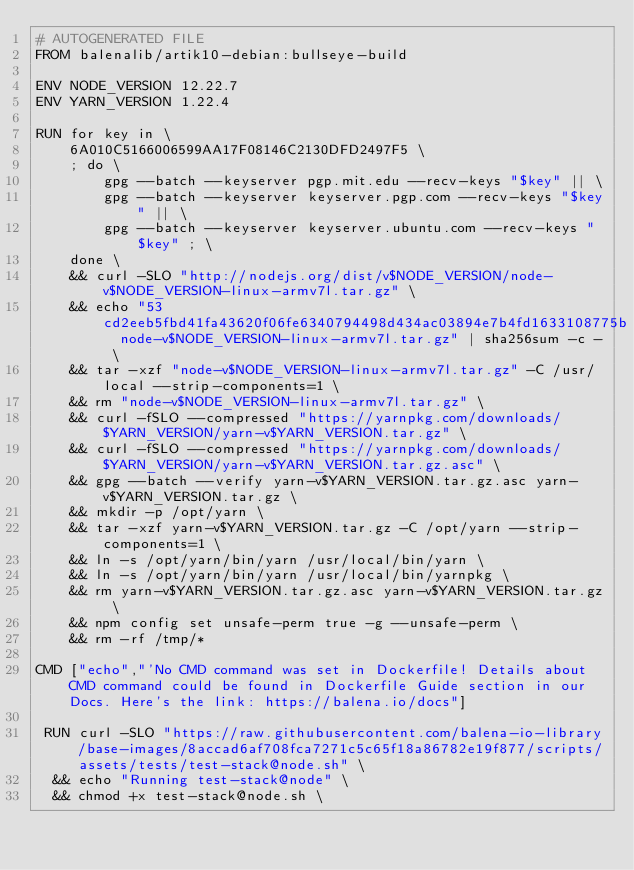<code> <loc_0><loc_0><loc_500><loc_500><_Dockerfile_># AUTOGENERATED FILE
FROM balenalib/artik10-debian:bullseye-build

ENV NODE_VERSION 12.22.7
ENV YARN_VERSION 1.22.4

RUN for key in \
	6A010C5166006599AA17F08146C2130DFD2497F5 \
	; do \
		gpg --batch --keyserver pgp.mit.edu --recv-keys "$key" || \
		gpg --batch --keyserver keyserver.pgp.com --recv-keys "$key" || \
		gpg --batch --keyserver keyserver.ubuntu.com --recv-keys "$key" ; \
	done \
	&& curl -SLO "http://nodejs.org/dist/v$NODE_VERSION/node-v$NODE_VERSION-linux-armv7l.tar.gz" \
	&& echo "53cd2eeb5fbd41fa43620f06fe6340794498d434ac03894e7b4fd1633108775b  node-v$NODE_VERSION-linux-armv7l.tar.gz" | sha256sum -c - \
	&& tar -xzf "node-v$NODE_VERSION-linux-armv7l.tar.gz" -C /usr/local --strip-components=1 \
	&& rm "node-v$NODE_VERSION-linux-armv7l.tar.gz" \
	&& curl -fSLO --compressed "https://yarnpkg.com/downloads/$YARN_VERSION/yarn-v$YARN_VERSION.tar.gz" \
	&& curl -fSLO --compressed "https://yarnpkg.com/downloads/$YARN_VERSION/yarn-v$YARN_VERSION.tar.gz.asc" \
	&& gpg --batch --verify yarn-v$YARN_VERSION.tar.gz.asc yarn-v$YARN_VERSION.tar.gz \
	&& mkdir -p /opt/yarn \
	&& tar -xzf yarn-v$YARN_VERSION.tar.gz -C /opt/yarn --strip-components=1 \
	&& ln -s /opt/yarn/bin/yarn /usr/local/bin/yarn \
	&& ln -s /opt/yarn/bin/yarn /usr/local/bin/yarnpkg \
	&& rm yarn-v$YARN_VERSION.tar.gz.asc yarn-v$YARN_VERSION.tar.gz \
	&& npm config set unsafe-perm true -g --unsafe-perm \
	&& rm -rf /tmp/*

CMD ["echo","'No CMD command was set in Dockerfile! Details about CMD command could be found in Dockerfile Guide section in our Docs. Here's the link: https://balena.io/docs"]

 RUN curl -SLO "https://raw.githubusercontent.com/balena-io-library/base-images/8accad6af708fca7271c5c65f18a86782e19f877/scripts/assets/tests/test-stack@node.sh" \
  && echo "Running test-stack@node" \
  && chmod +x test-stack@node.sh \</code> 